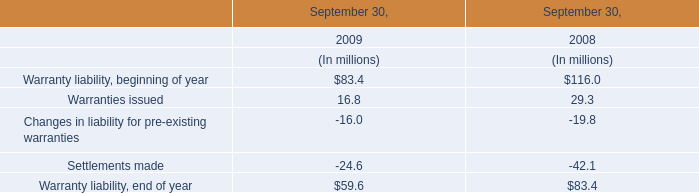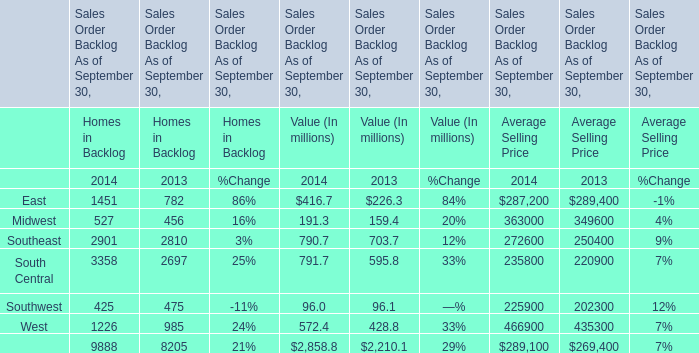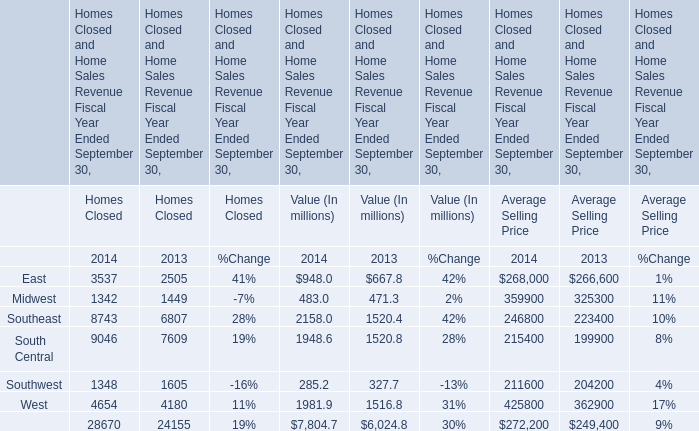What is the sum of elements for Value (In millions) in the range of 600 and 800 in 2014? (in million) 
Computations: (790.7 + 791.7)
Answer: 1582.4. 